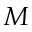<formula> <loc_0><loc_0><loc_500><loc_500>M</formula> 